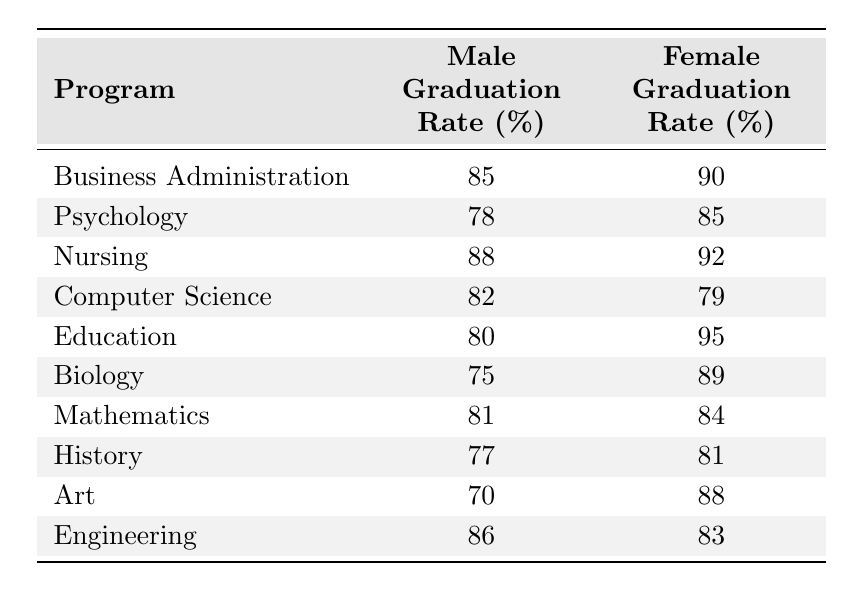What is the graduation rate for males in the Nursing program? The table indicates that the Male Graduation Rate for the Nursing program is 88%.
Answer: 88% What is the graduation rate for females in the Art program? According to the table, the Female Graduation Rate in the Art program is 88%.
Answer: 88% Which program has the highest Female Graduation Rate? By examining the Female Graduation Rates, Education has the highest rate at 95%.
Answer: Education What is the difference between the Male and Female Graduation Rates in Computer Science? The Male Graduation Rate in Computer Science is 82%, and the Female Graduation Rate is 79%. The difference is 82 - 79 = 3%.
Answer: 3% What is the average Male Graduation Rate across all programs? To find the average, add the Male Graduation Rates: 85 + 78 + 88 + 82 + 80 + 75 + 81 + 77 + 70 + 86 = 821. There are 10 programs, so the average is 821 / 10 = 82.1%.
Answer: 82.1% Is the Female Graduation Rate in Psychology higher than in Biology? In Psychology, the Female Graduation Rate is 85%, while in Biology it is 89%. Since 85 < 89, the statement is false.
Answer: No Which gender has a higher graduation rate in the Education program? The Male Graduation Rate is 80%, and the Female Graduation Rate is 95%. Since 95 > 80, females have a higher graduation rate in this program.
Answer: Female What is the combined total graduation rate for both genders in the History program? For the History program, the Male Graduation Rate is 77%, and the Female Graduation Rate is 81%. The combined total is 77 + 81 = 158%.
Answer: 158% Is it true that all programs have a Male Graduation Rate above 70%? Checking each Male Graduation Rate, only the Art program has a rate of 70%. All other programs are above 70%, thus the statement is true.
Answer: Yes Which program has the lowest Male Graduation Rate? By comparing the Male Graduation Rates, Biology has the lowest at 75%.
Answer: Biology 